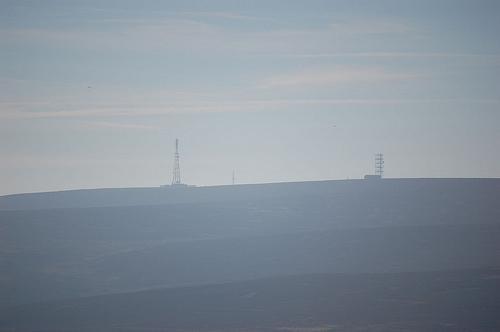How many things are in the distance?
Give a very brief answer. 2. 